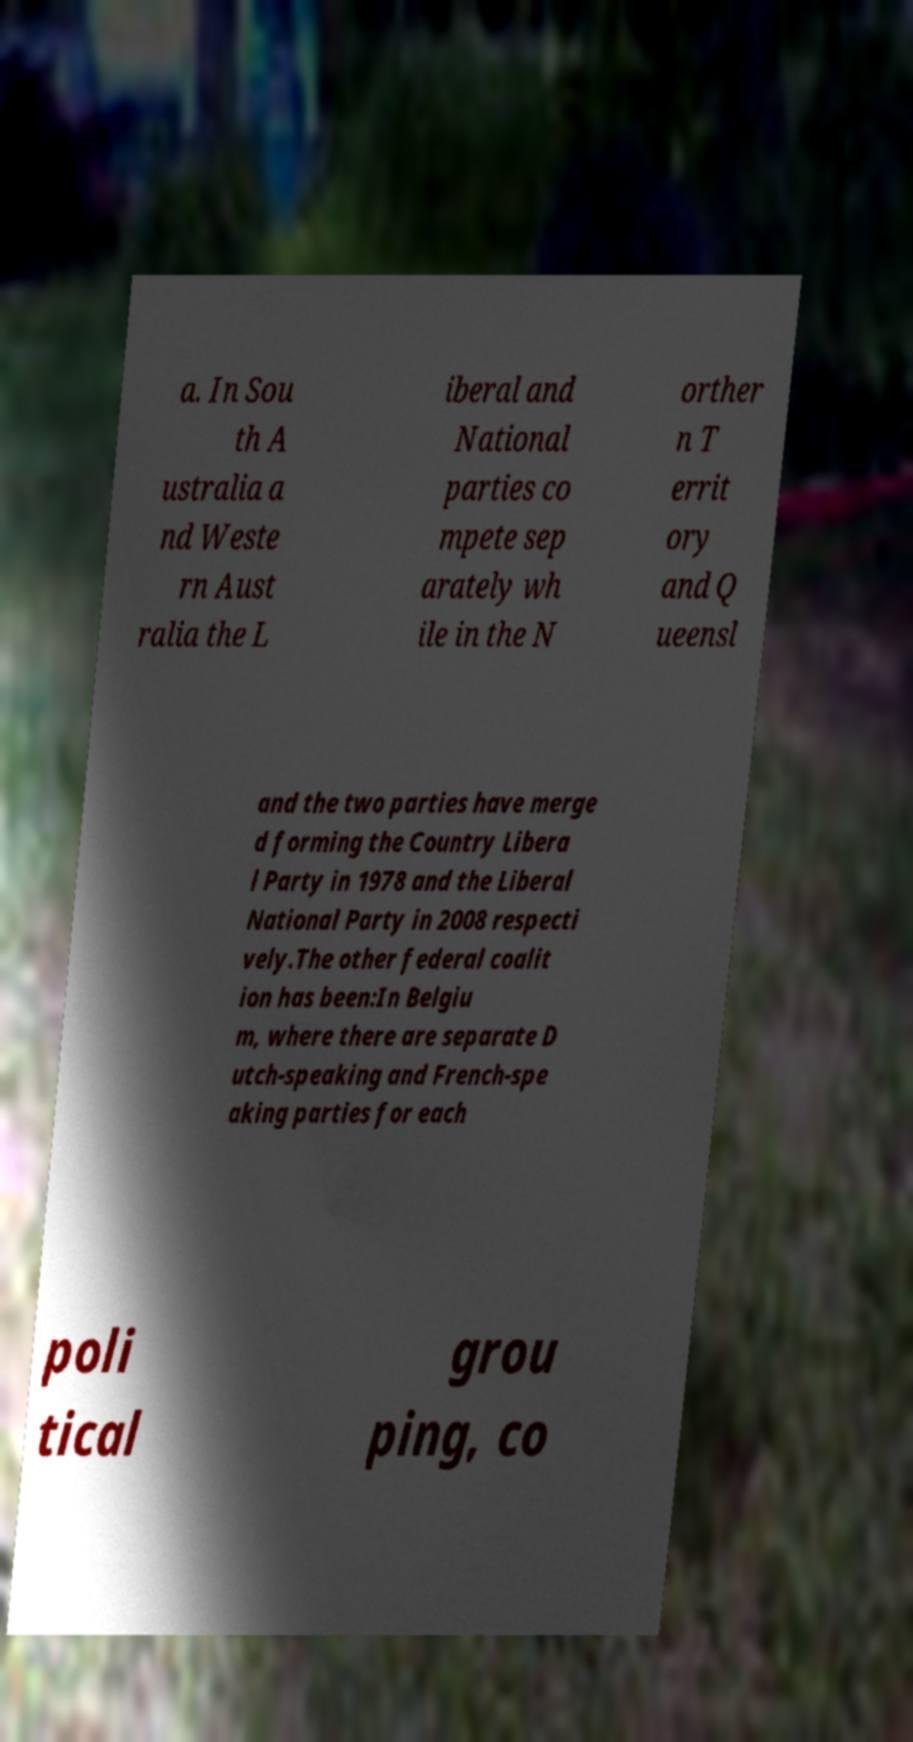Can you read and provide the text displayed in the image?This photo seems to have some interesting text. Can you extract and type it out for me? a. In Sou th A ustralia a nd Weste rn Aust ralia the L iberal and National parties co mpete sep arately wh ile in the N orther n T errit ory and Q ueensl and the two parties have merge d forming the Country Libera l Party in 1978 and the Liberal National Party in 2008 respecti vely.The other federal coalit ion has been:In Belgiu m, where there are separate D utch-speaking and French-spe aking parties for each poli tical grou ping, co 